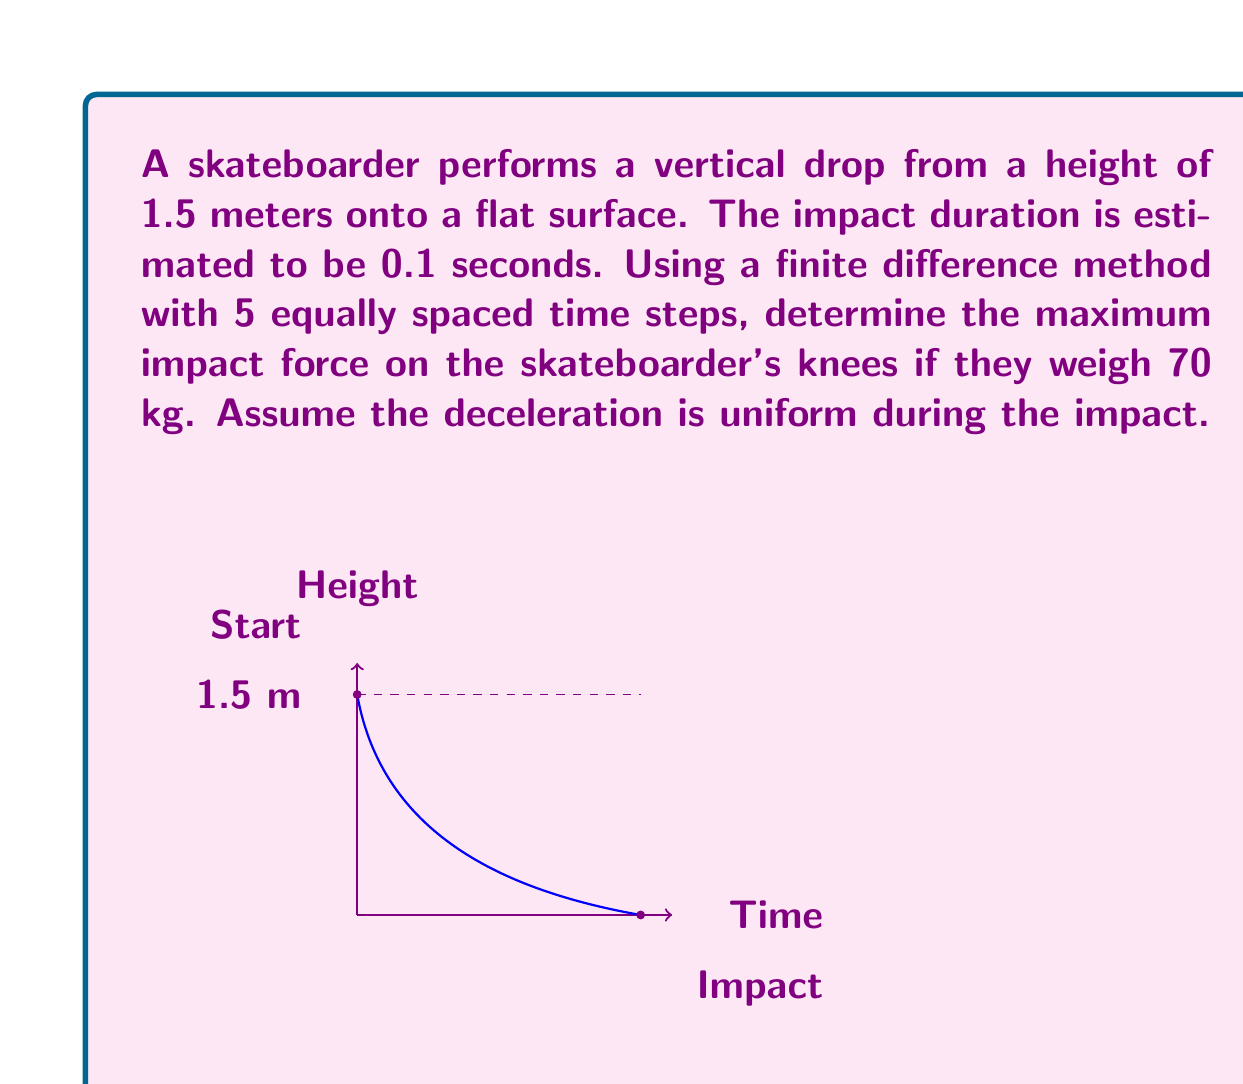Can you answer this question? To solve this problem using finite difference methods, we'll follow these steps:

1) First, calculate the initial velocity at impact:
   $$v = \sqrt{2gh} = \sqrt{2 \cdot 9.81 \cdot 1.5} = 5.42 \text{ m/s}$$

2) The impact duration is 0.1 seconds, divided into 5 equal steps. Each step is:
   $$\Delta t = 0.1 / 5 = 0.02 \text{ seconds}$$

3) Assuming uniform deceleration, we can calculate it:
   $$a = \frac{v - 0}{\Delta t} = \frac{5.42}{0.1} = 54.2 \text{ m/s}^2$$

4) Now, we'll use the central difference formula for acceleration:
   $$a_i = \frac{v_{i+1} - v_{i-1}}{2\Delta t}$$

5) We can rearrange this to find the velocity at each time step:
   $$v_{i+1} = v_{i-1} + 2a\Delta t$$

6) Starting with $v_0 = 5.42 \text{ m/s}$ and $v_1 = 4.336 \text{ m/s}$ (calculated using $v = v_0 - a\Delta t$), we can find the velocities at each step:

   $v_2 = v_0 + 2a\Delta t = 5.42 + 2 \cdot (-54.2) \cdot 0.02 = 3.252 \text{ m/s}$
   $v_3 = v_1 + 2a\Delta t = 4.336 + 2 \cdot (-54.2) \cdot 0.02 = 2.168 \text{ m/s}$
   $v_4 = v_2 + 2a\Delta t = 3.252 + 2 \cdot (-54.2) \cdot 0.02 = 1.084 \text{ m/s}$
   $v_5 = v_3 + 2a\Delta t = 2.168 + 2 \cdot (-54.2) \cdot 0.02 = 0 \text{ m/s}$

7) The maximum force occurs at the beginning of the impact. We can calculate it using Newton's Second Law:
   $$F = ma = 70 \cdot 54.2 = 3794 \text{ N}$$

Therefore, the maximum impact force on the skateboarder's knees is approximately 3794 N.
Answer: 3794 N 